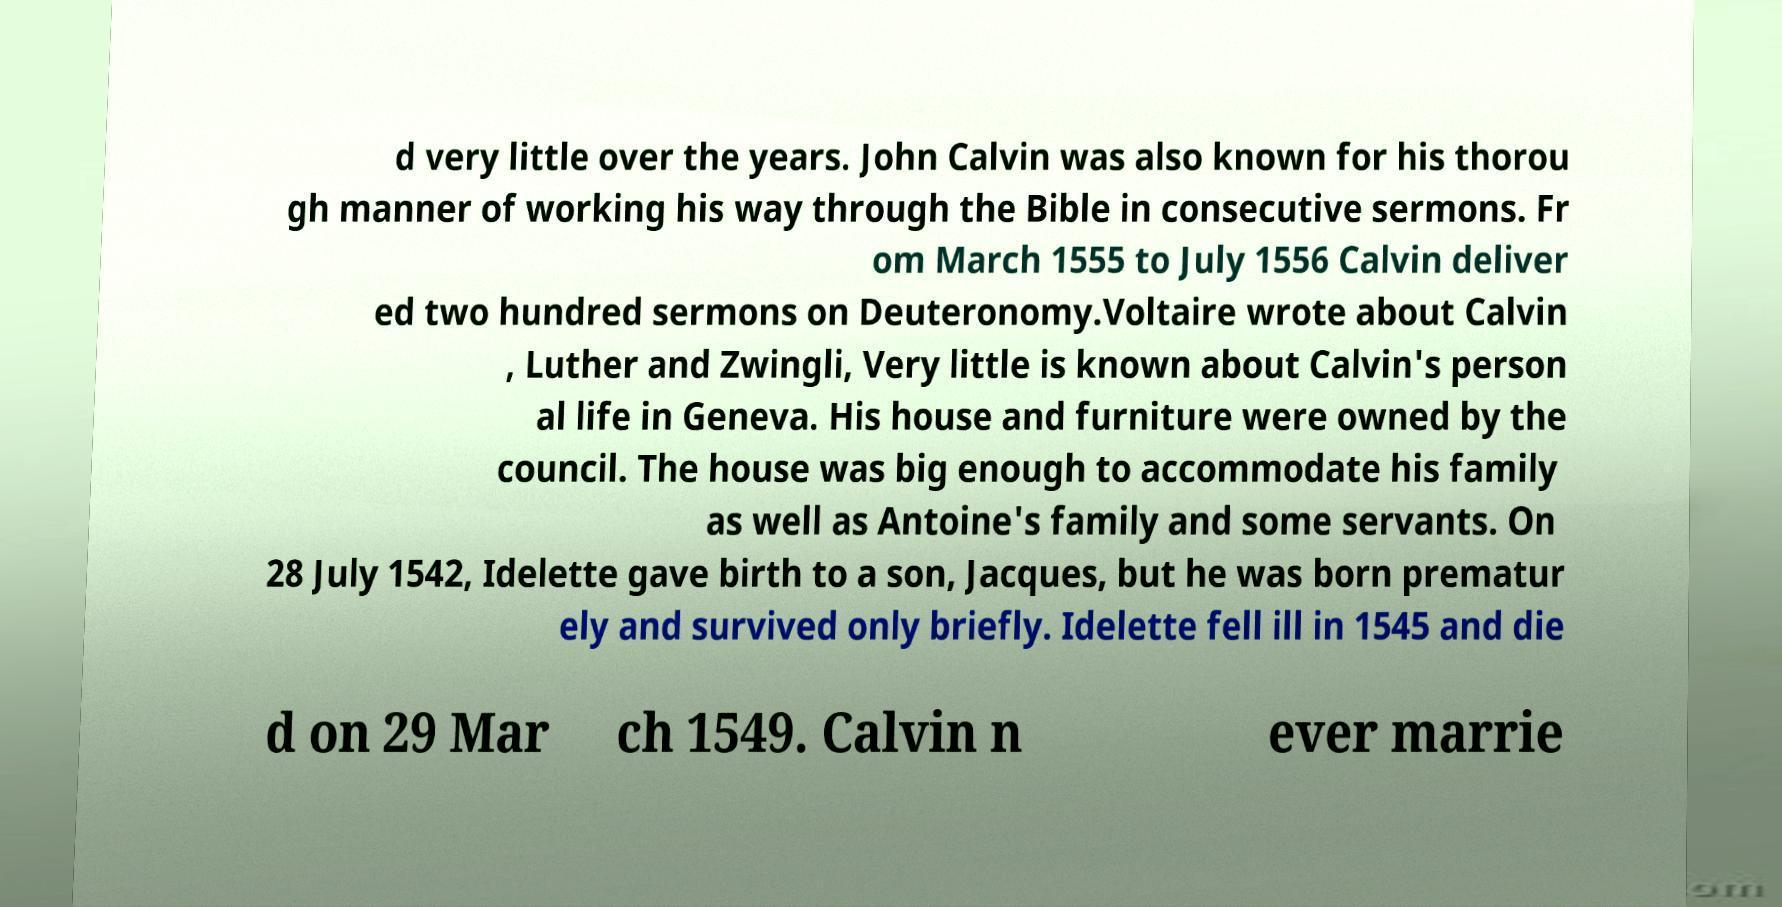Could you assist in decoding the text presented in this image and type it out clearly? d very little over the years. John Calvin was also known for his thorou gh manner of working his way through the Bible in consecutive sermons. Fr om March 1555 to July 1556 Calvin deliver ed two hundred sermons on Deuteronomy.Voltaire wrote about Calvin , Luther and Zwingli, Very little is known about Calvin's person al life in Geneva. His house and furniture were owned by the council. The house was big enough to accommodate his family as well as Antoine's family and some servants. On 28 July 1542, Idelette gave birth to a son, Jacques, but he was born prematur ely and survived only briefly. Idelette fell ill in 1545 and die d on 29 Mar ch 1549. Calvin n ever marrie 